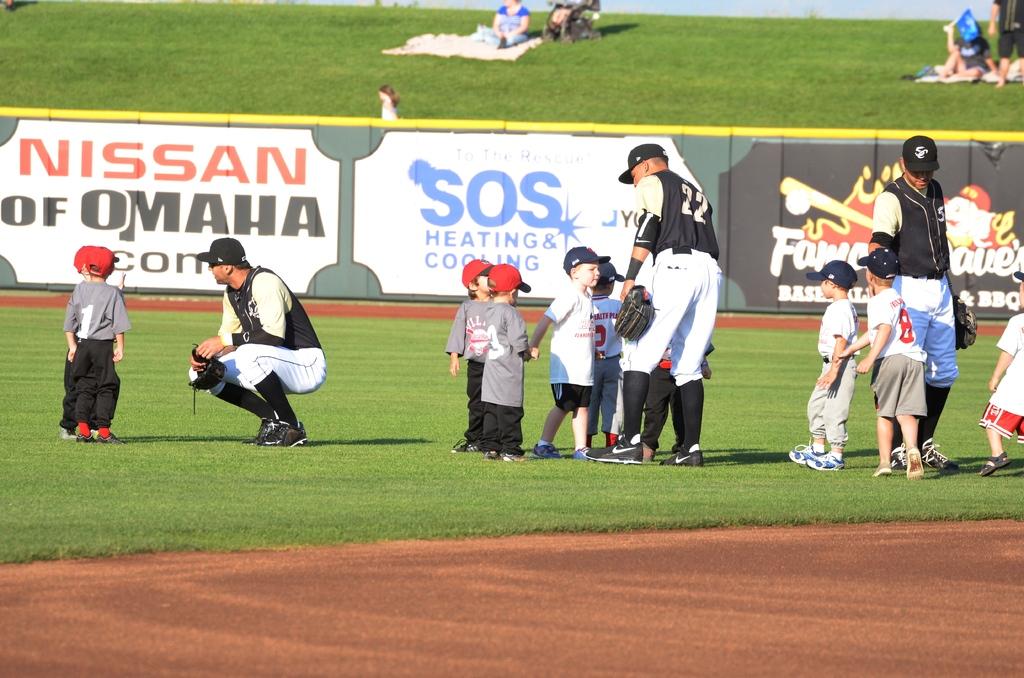What companies sponsor this event?
Your answer should be compact. Nissan. What is the jersey number of the middle athlete?
Provide a short and direct response. 22. 